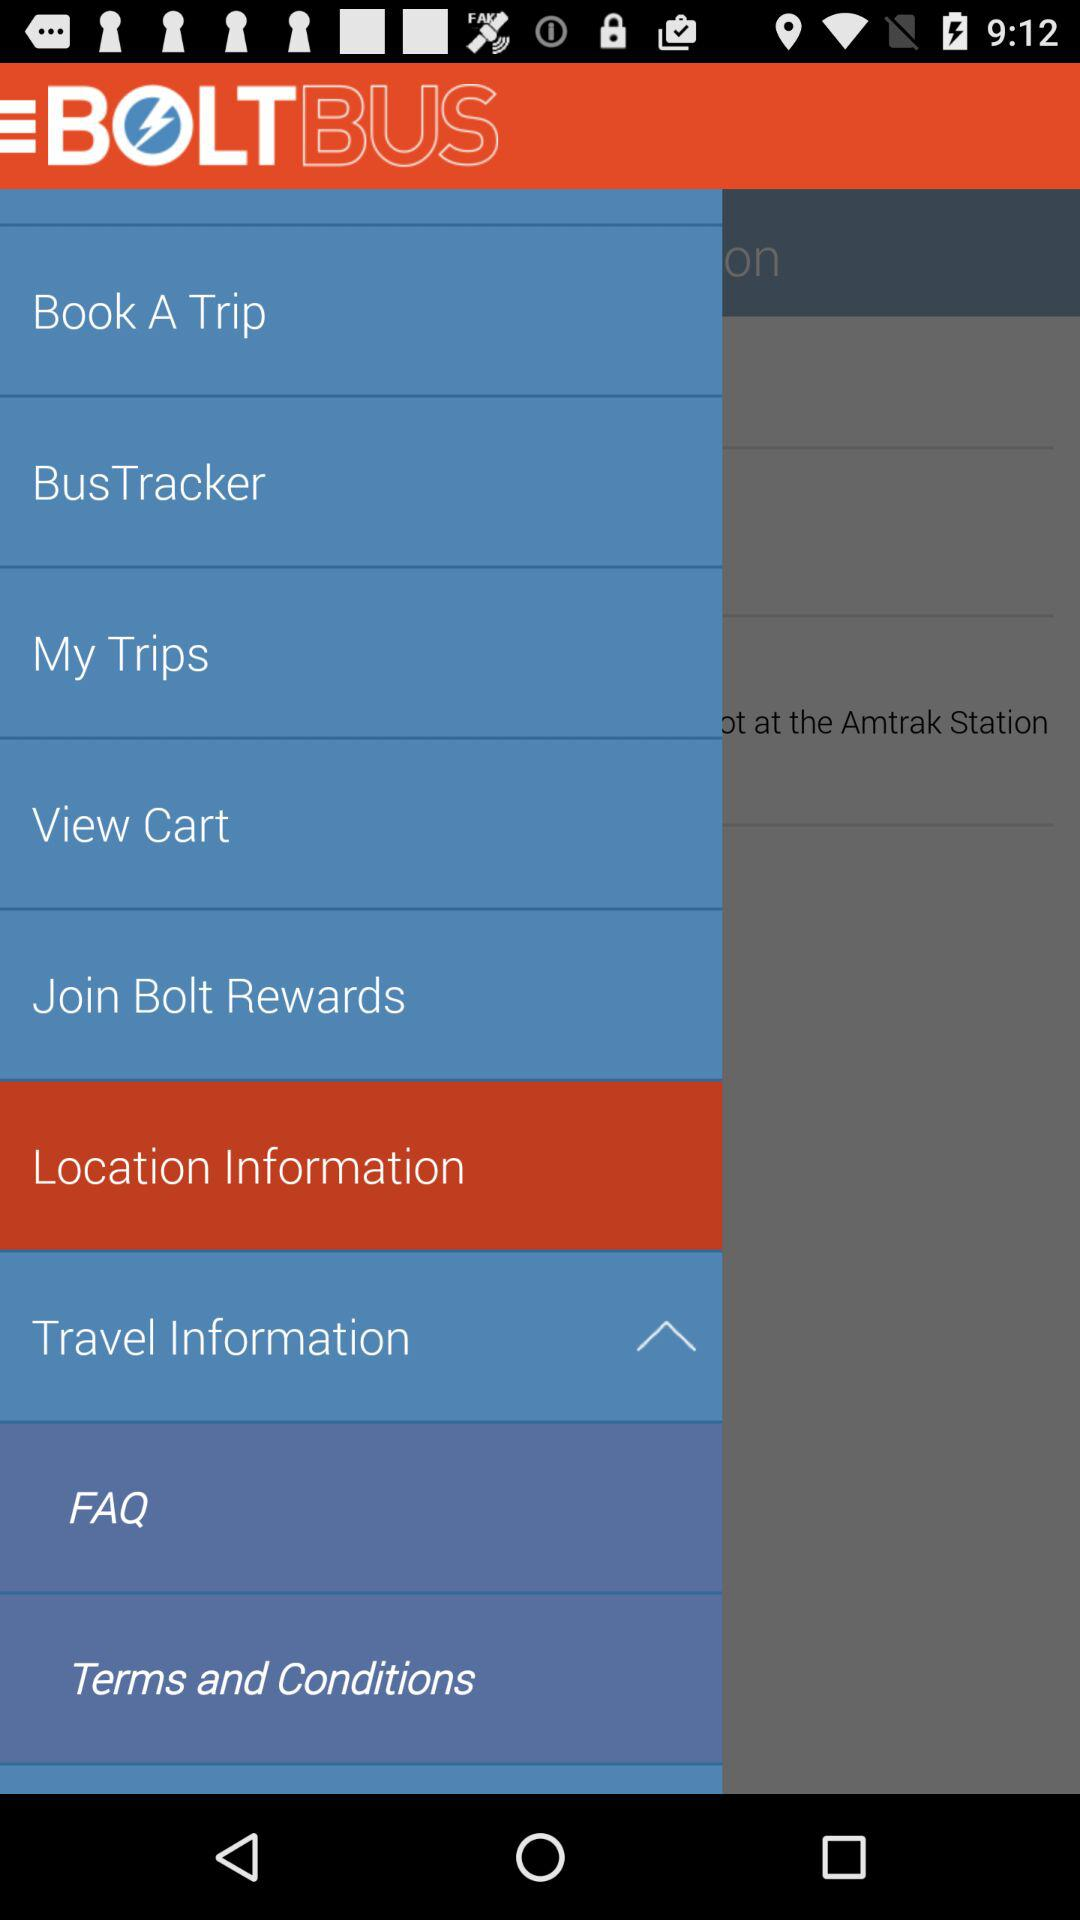What is the location?
When the provided information is insufficient, respond with <no answer>. <no answer> 